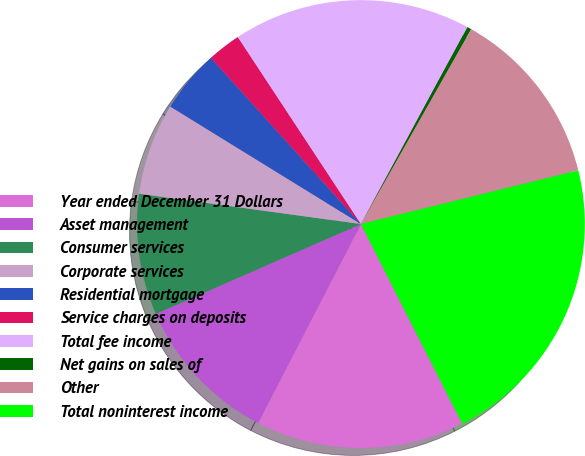<chart> <loc_0><loc_0><loc_500><loc_500><pie_chart><fcel>Year ended December 31 Dollars<fcel>Asset management<fcel>Consumer services<fcel>Corporate services<fcel>Residential mortgage<fcel>Service charges on deposits<fcel>Total fee income<fcel>Net gains on sales of<fcel>Other<fcel>Total noninterest income<nl><fcel>15.06%<fcel>10.84%<fcel>8.74%<fcel>6.63%<fcel>4.52%<fcel>2.42%<fcel>17.16%<fcel>0.31%<fcel>12.95%<fcel>21.38%<nl></chart> 